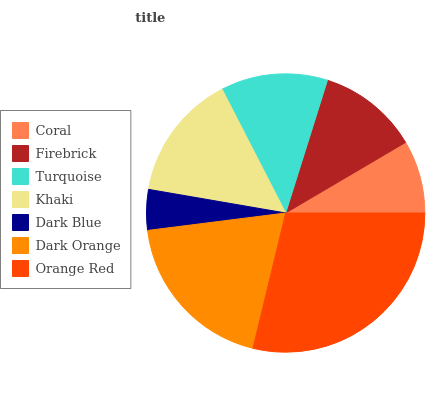Is Dark Blue the minimum?
Answer yes or no. Yes. Is Orange Red the maximum?
Answer yes or no. Yes. Is Firebrick the minimum?
Answer yes or no. No. Is Firebrick the maximum?
Answer yes or no. No. Is Firebrick greater than Coral?
Answer yes or no. Yes. Is Coral less than Firebrick?
Answer yes or no. Yes. Is Coral greater than Firebrick?
Answer yes or no. No. Is Firebrick less than Coral?
Answer yes or no. No. Is Turquoise the high median?
Answer yes or no. Yes. Is Turquoise the low median?
Answer yes or no. Yes. Is Coral the high median?
Answer yes or no. No. Is Orange Red the low median?
Answer yes or no. No. 